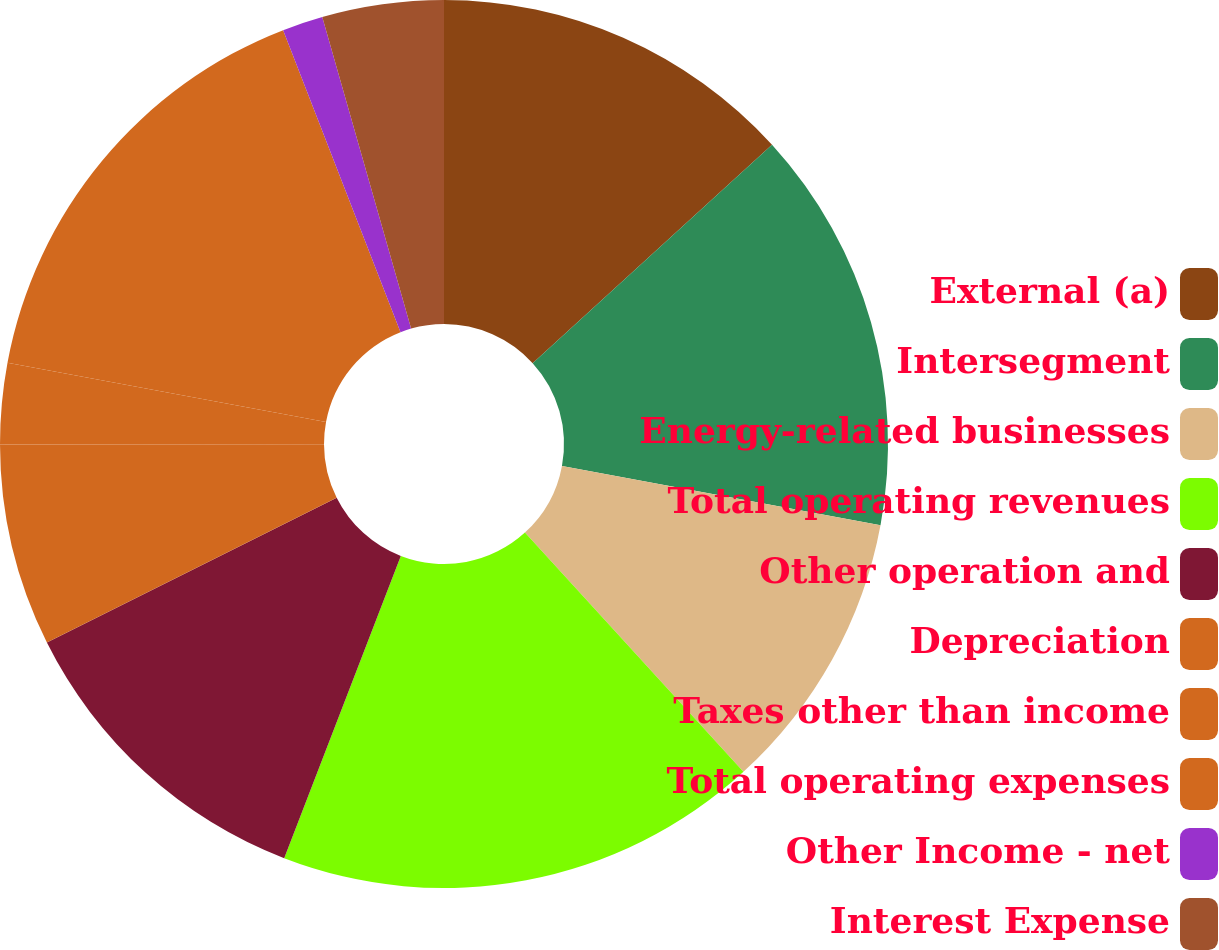<chart> <loc_0><loc_0><loc_500><loc_500><pie_chart><fcel>External (a)<fcel>Intersegment<fcel>Energy-related businesses<fcel>Total operating revenues<fcel>Other operation and<fcel>Depreciation<fcel>Taxes other than income<fcel>Total operating expenses<fcel>Other Income - net<fcel>Interest Expense<nl><fcel>13.23%<fcel>14.7%<fcel>10.29%<fcel>17.64%<fcel>11.76%<fcel>7.36%<fcel>2.95%<fcel>16.17%<fcel>1.48%<fcel>4.42%<nl></chart> 